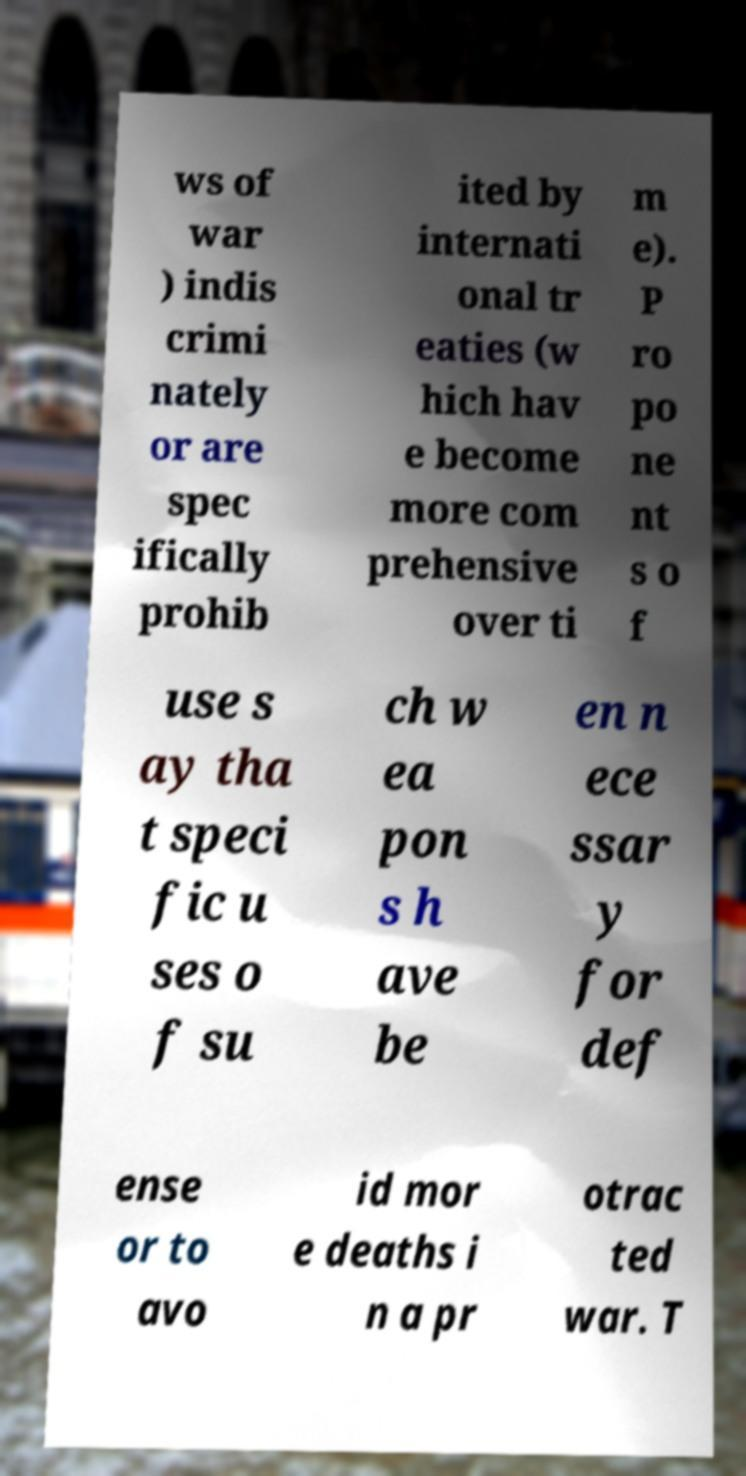Can you read and provide the text displayed in the image?This photo seems to have some interesting text. Can you extract and type it out for me? ws of war ) indis crimi nately or are spec ifically prohib ited by internati onal tr eaties (w hich hav e become more com prehensive over ti m e). P ro po ne nt s o f use s ay tha t speci fic u ses o f su ch w ea pon s h ave be en n ece ssar y for def ense or to avo id mor e deaths i n a pr otrac ted war. T 